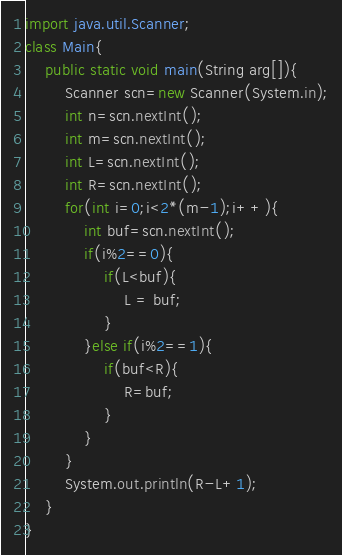Convert code to text. <code><loc_0><loc_0><loc_500><loc_500><_Java_>import java.util.Scanner;
class Main{
    public static void main(String arg[]){
        Scanner scn=new Scanner(System.in);
        int n=scn.nextInt();
        int m=scn.nextInt();
        int L=scn.nextInt();
        int R=scn.nextInt();
        for(int i=0;i<2*(m-1);i++){
            int buf=scn.nextInt();
            if(i%2==0){
                if(L<buf){
                    L = buf;
                }
            }else if(i%2==1){
                if(buf<R){
                    R=buf;
                }
            }
        }
        System.out.println(R-L+1);
    }
}
</code> 